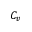<formula> <loc_0><loc_0><loc_500><loc_500>C _ { v }</formula> 